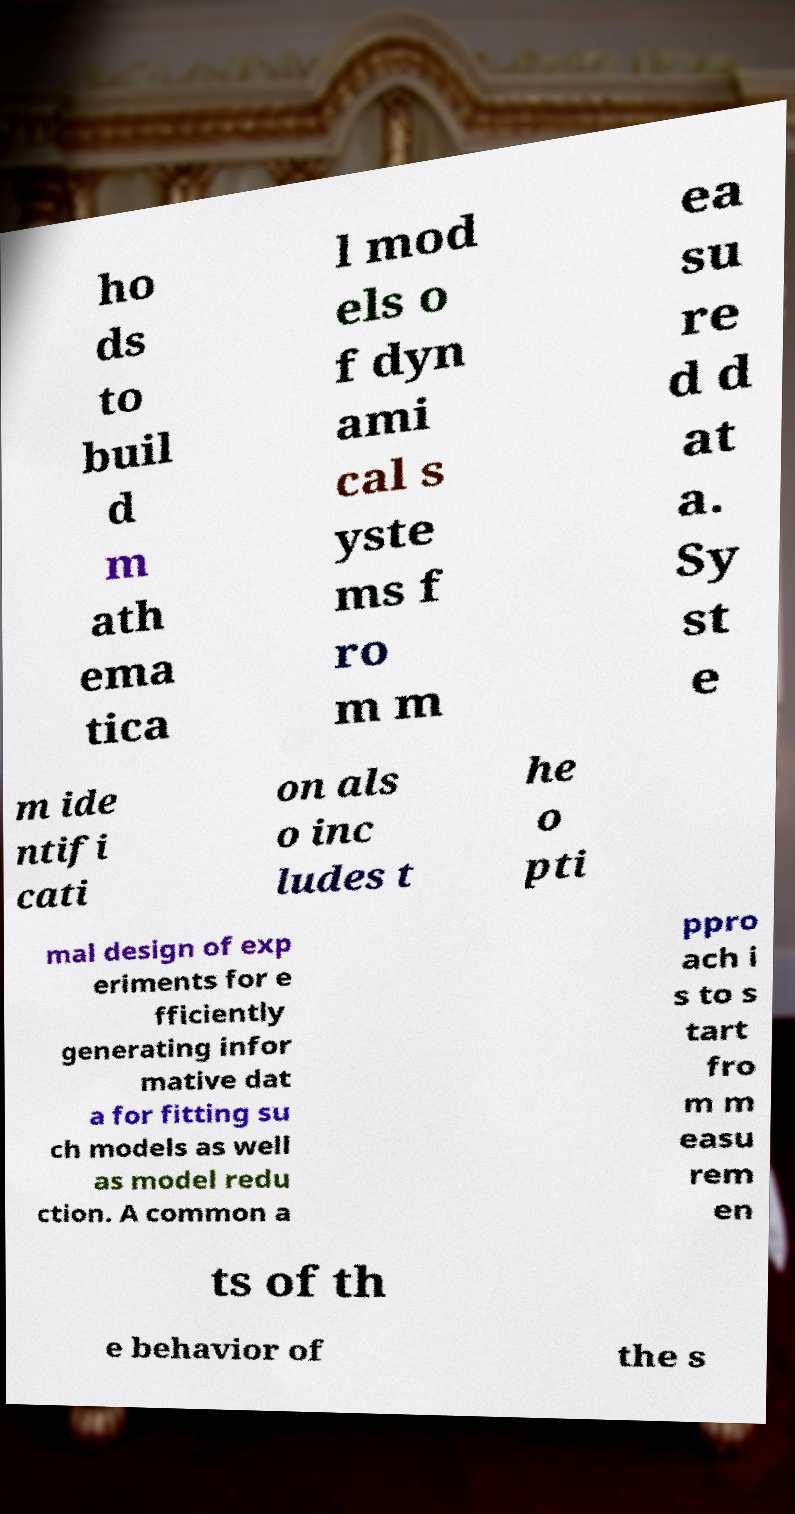For documentation purposes, I need the text within this image transcribed. Could you provide that? ho ds to buil d m ath ema tica l mod els o f dyn ami cal s yste ms f ro m m ea su re d d at a. Sy st e m ide ntifi cati on als o inc ludes t he o pti mal design of exp eriments for e fficiently generating infor mative dat a for fitting su ch models as well as model redu ction. A common a ppro ach i s to s tart fro m m easu rem en ts of th e behavior of the s 